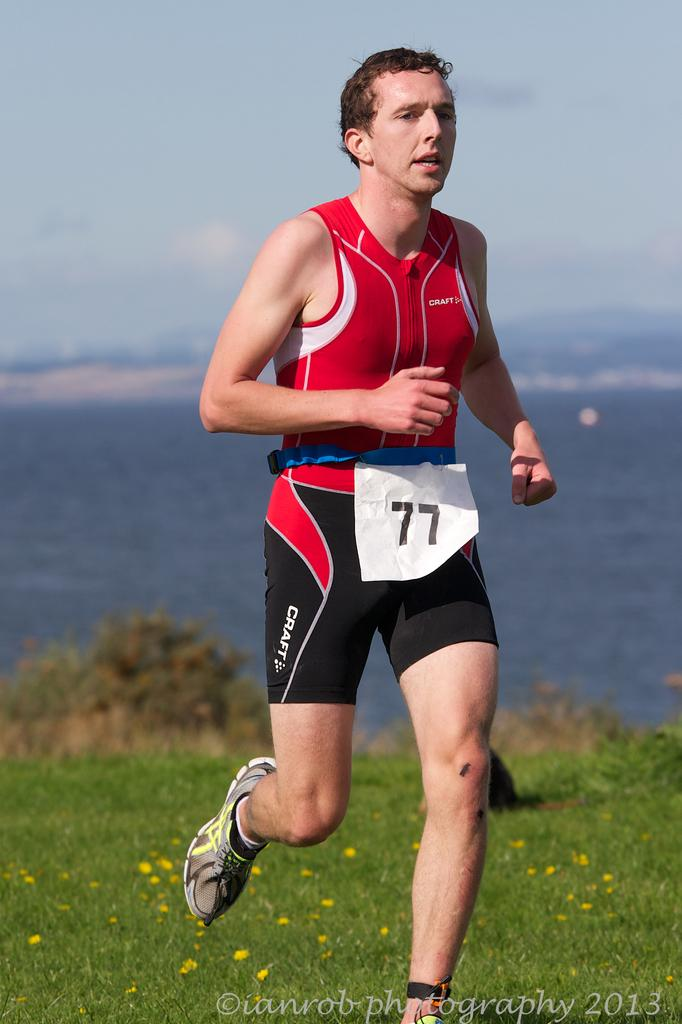Provide a one-sentence caption for the provided image. Runner number 77 running a cross country race. 